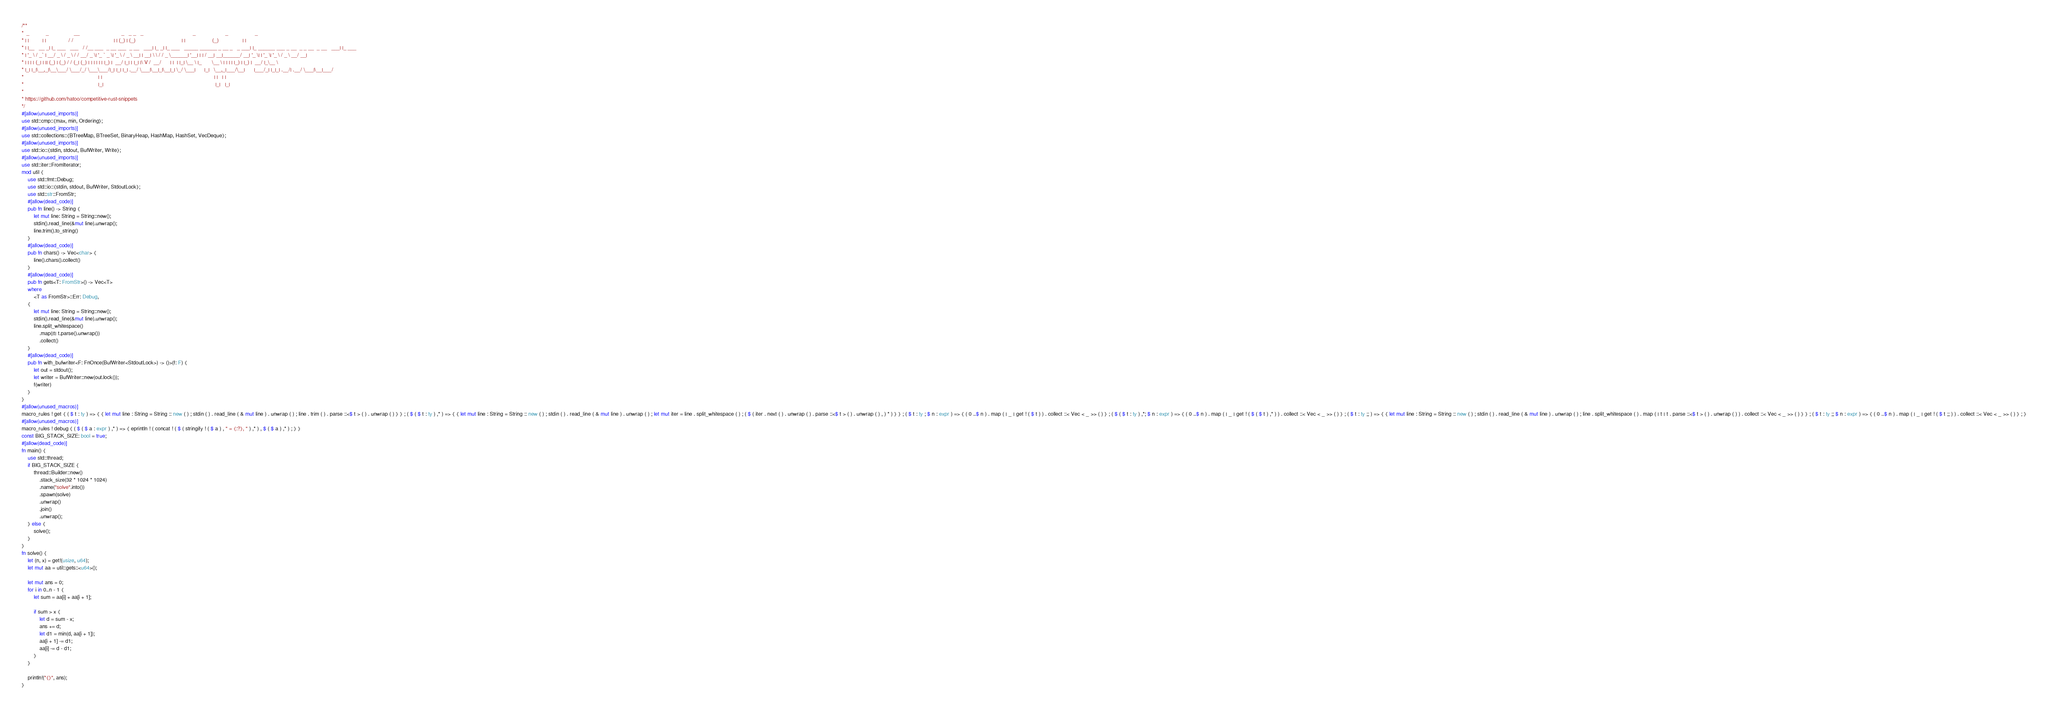Convert code to text. <code><loc_0><loc_0><loc_500><loc_500><_Rust_>/**
*  _           _                 __                            _   _ _   _                                 _                    _                  _
* | |         | |               / /                           | | (_) | (_)                               | |                  (_)                | |
* | |__   __ _| |_ ___   ___   / /__ ___  _ __ ___  _ __   ___| |_ _| |_ ___   _____ ______ _ __ _   _ ___| |_ ______ ___ _ __  _ _ __  _ __   ___| |_ ___
* | '_ \ / _` | __/ _ \ / _ \ / / __/ _ \| '_ ` _ \| '_ \ / _ \ __| | __| \ \ / / _ \______| '__| | | / __| __|______/ __| '_ \| | '_ \| '_ \ / _ \ __/ __|
* | | | | (_| | || (_) | (_) / / (_| (_) | | | | | | |_) |  __/ |_| | |_| |\ V /  __/      | |  | |_| \__ \ |_       \__ \ | | | | |_) | |_) |  __/ |_\__ \
* |_| |_|\__,_|\__\___/ \___/_/ \___\___/|_| |_| |_| .__/ \___|\__|_|\__|_| \_/ \___|      |_|   \__,_|___/\__|      |___/_| |_|_| .__/| .__/ \___|\__|___/
*                                                  | |                                                                           | |   | |
*                                                  |_|                                                                           |_|   |_|
*
* https://github.com/hatoo/competitive-rust-snippets
*/
#[allow(unused_imports)]
use std::cmp::{max, min, Ordering};
#[allow(unused_imports)]
use std::collections::{BTreeMap, BTreeSet, BinaryHeap, HashMap, HashSet, VecDeque};
#[allow(unused_imports)]
use std::io::{stdin, stdout, BufWriter, Write};
#[allow(unused_imports)]
use std::iter::FromIterator;
mod util {
    use std::fmt::Debug;
    use std::io::{stdin, stdout, BufWriter, StdoutLock};
    use std::str::FromStr;
    #[allow(dead_code)]
    pub fn line() -> String {
        let mut line: String = String::new();
        stdin().read_line(&mut line).unwrap();
        line.trim().to_string()
    }
    #[allow(dead_code)]
    pub fn chars() -> Vec<char> {
        line().chars().collect()
    }
    #[allow(dead_code)]
    pub fn gets<T: FromStr>() -> Vec<T>
    where
        <T as FromStr>::Err: Debug,
    {
        let mut line: String = String::new();
        stdin().read_line(&mut line).unwrap();
        line.split_whitespace()
            .map(|t| t.parse().unwrap())
            .collect()
    }
    #[allow(dead_code)]
    pub fn with_bufwriter<F: FnOnce(BufWriter<StdoutLock>) -> ()>(f: F) {
        let out = stdout();
        let writer = BufWriter::new(out.lock());
        f(writer)
    }
}
#[allow(unused_macros)]
macro_rules ! get { ( $ t : ty ) => { { let mut line : String = String :: new ( ) ; stdin ( ) . read_line ( & mut line ) . unwrap ( ) ; line . trim ( ) . parse ::<$ t > ( ) . unwrap ( ) } } ; ( $ ( $ t : ty ) ,* ) => { { let mut line : String = String :: new ( ) ; stdin ( ) . read_line ( & mut line ) . unwrap ( ) ; let mut iter = line . split_whitespace ( ) ; ( $ ( iter . next ( ) . unwrap ( ) . parse ::<$ t > ( ) . unwrap ( ) , ) * ) } } ; ( $ t : ty ; $ n : expr ) => { ( 0 ..$ n ) . map ( | _ | get ! ( $ t ) ) . collect ::< Vec < _ >> ( ) } ; ( $ ( $ t : ty ) ,*; $ n : expr ) => { ( 0 ..$ n ) . map ( | _ | get ! ( $ ( $ t ) ,* ) ) . collect ::< Vec < _ >> ( ) } ; ( $ t : ty ;; ) => { { let mut line : String = String :: new ( ) ; stdin ( ) . read_line ( & mut line ) . unwrap ( ) ; line . split_whitespace ( ) . map ( | t | t . parse ::<$ t > ( ) . unwrap ( ) ) . collect ::< Vec < _ >> ( ) } } ; ( $ t : ty ;; $ n : expr ) => { ( 0 ..$ n ) . map ( | _ | get ! ( $ t ;; ) ) . collect ::< Vec < _ >> ( ) } ; }
#[allow(unused_macros)]
macro_rules ! debug { ( $ ( $ a : expr ) ,* ) => { eprintln ! ( concat ! ( $ ( stringify ! ( $ a ) , " = {:?}, " ) ,* ) , $ ( $ a ) ,* ) ; } }
const BIG_STACK_SIZE: bool = true;
#[allow(dead_code)]
fn main() {
    use std::thread;
    if BIG_STACK_SIZE {
        thread::Builder::new()
            .stack_size(32 * 1024 * 1024)
            .name("solve".into())
            .spawn(solve)
            .unwrap()
            .join()
            .unwrap();
    } else {
        solve();
    }
}
fn solve() {
    let (n, x) = get!(usize, u64);
    let mut aa = util::gets::<u64>();

    let mut ans = 0;
    for i in 0..n - 1 {
        let sum = aa[i] + aa[i + 1];

        if sum > x {
            let d = sum - x;
            ans += d;
            let d1 = min(d, aa[i + 1]);
            aa[i + 1] -= d1;
            aa[i] -= d - d1;
        }
    }

    println!("{}", ans);
}
</code> 